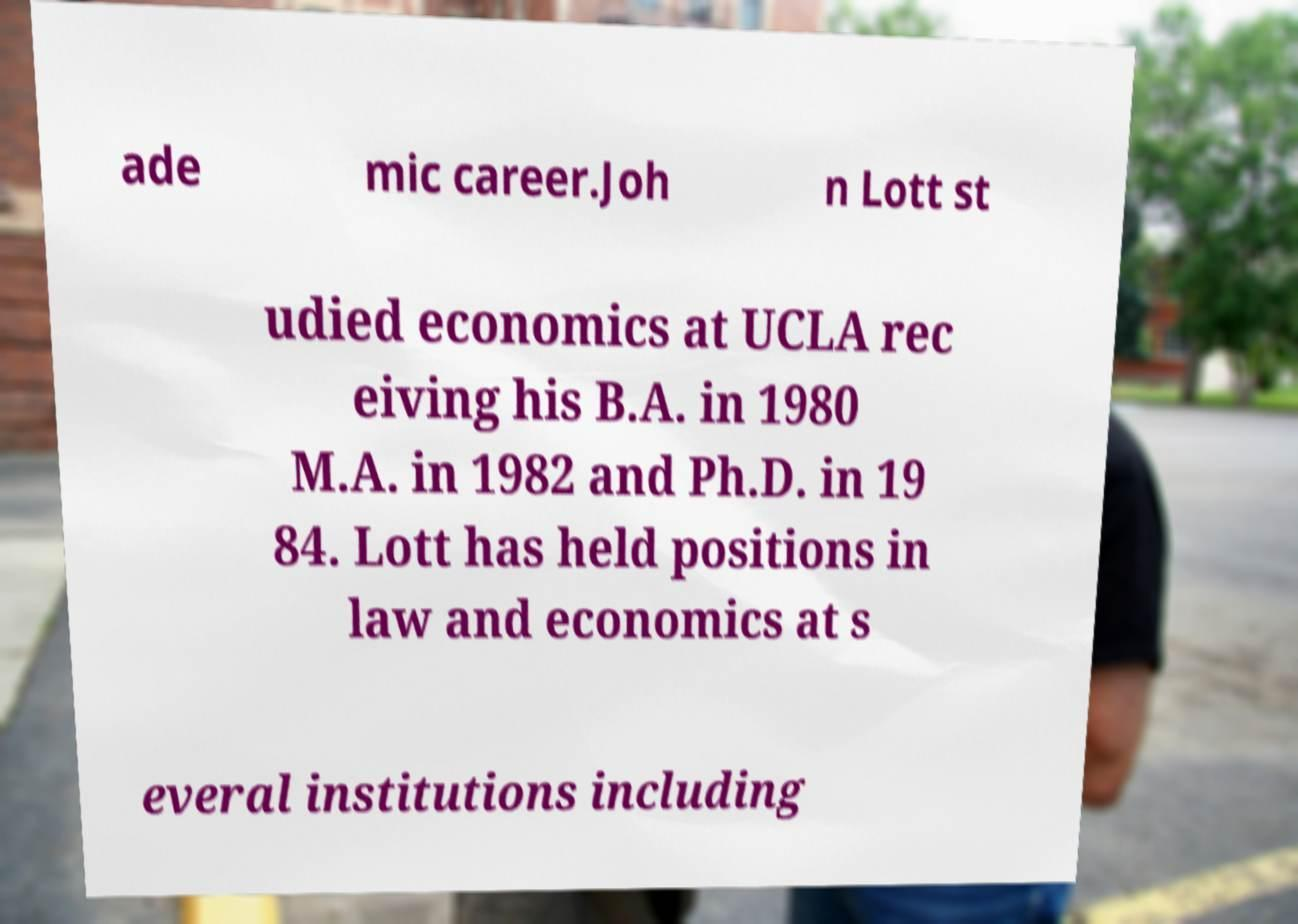What messages or text are displayed in this image? I need them in a readable, typed format. ade mic career.Joh n Lott st udied economics at UCLA rec eiving his B.A. in 1980 M.A. in 1982 and Ph.D. in 19 84. Lott has held positions in law and economics at s everal institutions including 